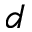Convert formula to latex. <formula><loc_0><loc_0><loc_500><loc_500>d</formula> 